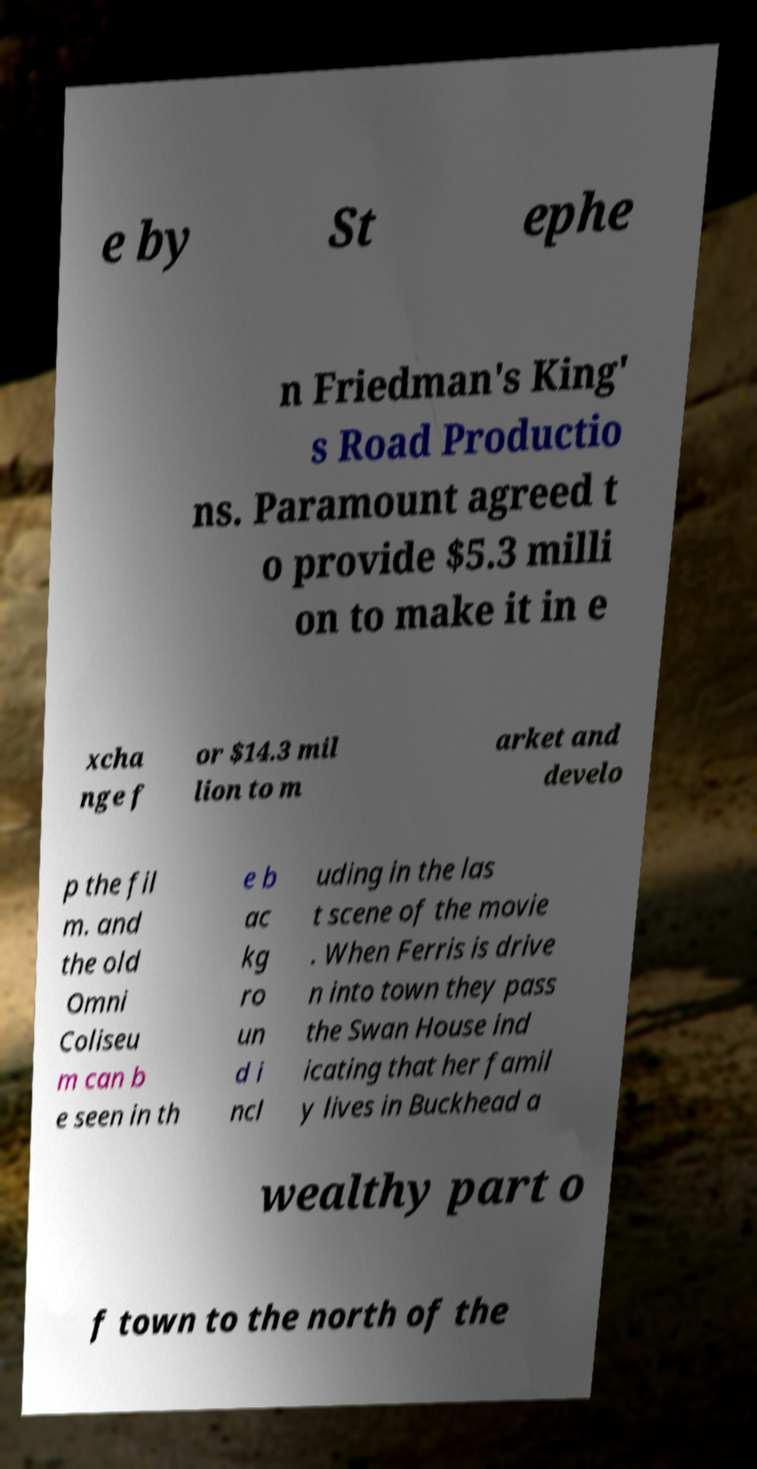Could you extract and type out the text from this image? e by St ephe n Friedman's King' s Road Productio ns. Paramount agreed t o provide $5.3 milli on to make it in e xcha nge f or $14.3 mil lion to m arket and develo p the fil m. and the old Omni Coliseu m can b e seen in th e b ac kg ro un d i ncl uding in the las t scene of the movie . When Ferris is drive n into town they pass the Swan House ind icating that her famil y lives in Buckhead a wealthy part o f town to the north of the 